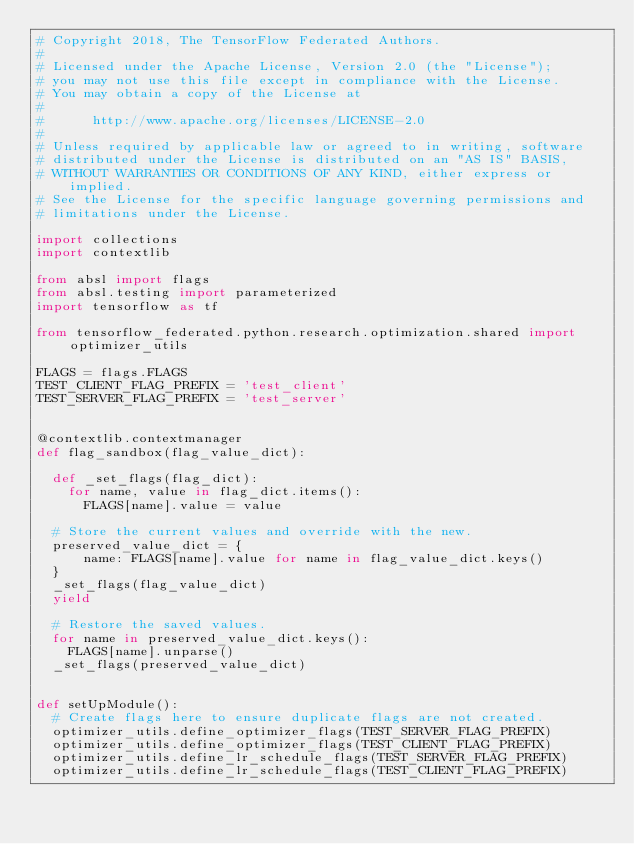Convert code to text. <code><loc_0><loc_0><loc_500><loc_500><_Python_># Copyright 2018, The TensorFlow Federated Authors.
#
# Licensed under the Apache License, Version 2.0 (the "License");
# you may not use this file except in compliance with the License.
# You may obtain a copy of the License at
#
#      http://www.apache.org/licenses/LICENSE-2.0
#
# Unless required by applicable law or agreed to in writing, software
# distributed under the License is distributed on an "AS IS" BASIS,
# WITHOUT WARRANTIES OR CONDITIONS OF ANY KIND, either express or implied.
# See the License for the specific language governing permissions and
# limitations under the License.

import collections
import contextlib

from absl import flags
from absl.testing import parameterized
import tensorflow as tf

from tensorflow_federated.python.research.optimization.shared import optimizer_utils

FLAGS = flags.FLAGS
TEST_CLIENT_FLAG_PREFIX = 'test_client'
TEST_SERVER_FLAG_PREFIX = 'test_server'


@contextlib.contextmanager
def flag_sandbox(flag_value_dict):

  def _set_flags(flag_dict):
    for name, value in flag_dict.items():
      FLAGS[name].value = value

  # Store the current values and override with the new.
  preserved_value_dict = {
      name: FLAGS[name].value for name in flag_value_dict.keys()
  }
  _set_flags(flag_value_dict)
  yield

  # Restore the saved values.
  for name in preserved_value_dict.keys():
    FLAGS[name].unparse()
  _set_flags(preserved_value_dict)


def setUpModule():
  # Create flags here to ensure duplicate flags are not created.
  optimizer_utils.define_optimizer_flags(TEST_SERVER_FLAG_PREFIX)
  optimizer_utils.define_optimizer_flags(TEST_CLIENT_FLAG_PREFIX)
  optimizer_utils.define_lr_schedule_flags(TEST_SERVER_FLAG_PREFIX)
  optimizer_utils.define_lr_schedule_flags(TEST_CLIENT_FLAG_PREFIX)
</code> 